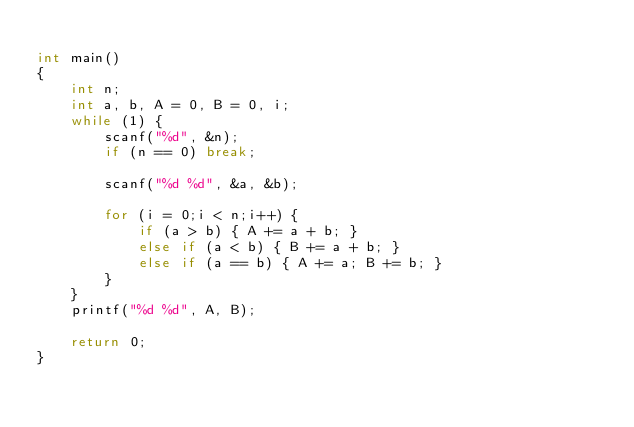Convert code to text. <code><loc_0><loc_0><loc_500><loc_500><_C_>
int main()
{
	int n;
	int a, b, A = 0, B = 0, i;
	while (1) {
		scanf("%d", &n);
		if (n == 0) break;

		scanf("%d %d", &a, &b);

		for (i = 0;i < n;i++) {
			if (a > b) { A += a + b; }
			else if (a < b) { B += a + b; }
			else if (a == b) { A += a; B += b; }
		}
	}
	printf("%d %d", A, B);

	return 0;
}</code> 